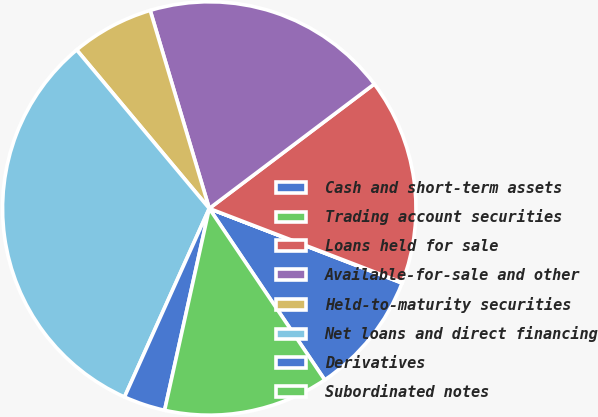<chart> <loc_0><loc_0><loc_500><loc_500><pie_chart><fcel>Cash and short-term assets<fcel>Trading account securities<fcel>Loans held for sale<fcel>Available-for-sale and other<fcel>Held-to-maturity securities<fcel>Net loans and direct financing<fcel>Derivatives<fcel>Subordinated notes<nl><fcel>9.69%<fcel>0.04%<fcel>16.12%<fcel>19.33%<fcel>6.47%<fcel>32.19%<fcel>3.26%<fcel>12.9%<nl></chart> 